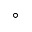Convert formula to latex. <formula><loc_0><loc_0><loc_500><loc_500>^ { \circ }</formula> 